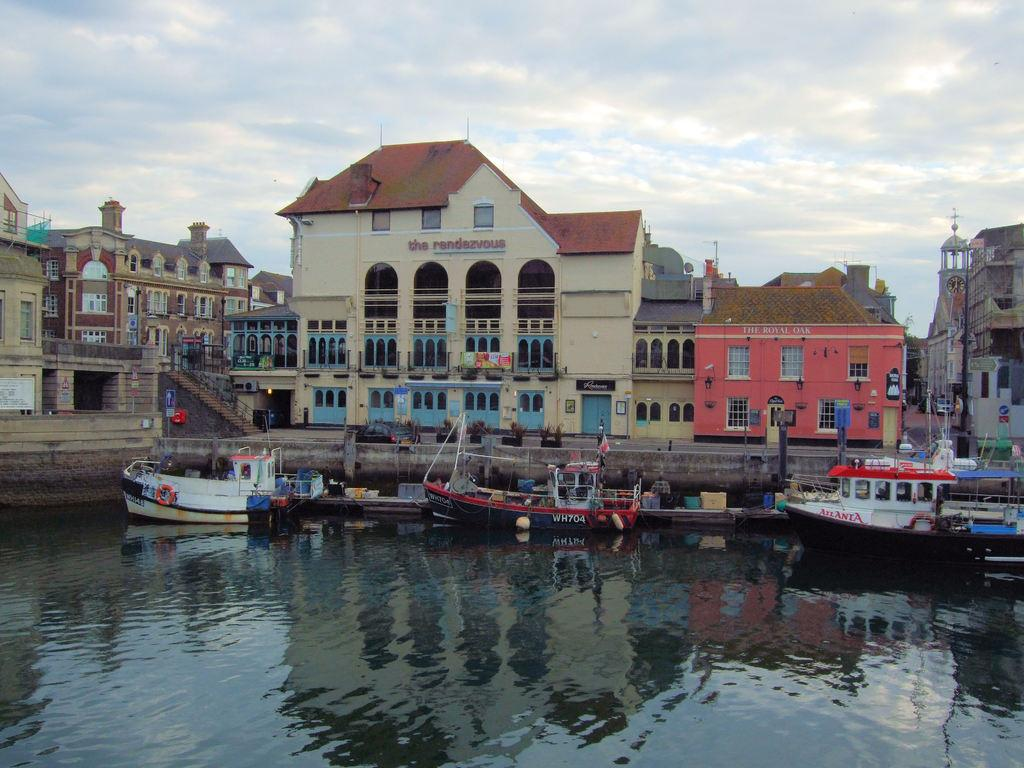<image>
Render a clear and concise summary of the photo. A few boats parked in front of a pier next to the Rendezvous building. 